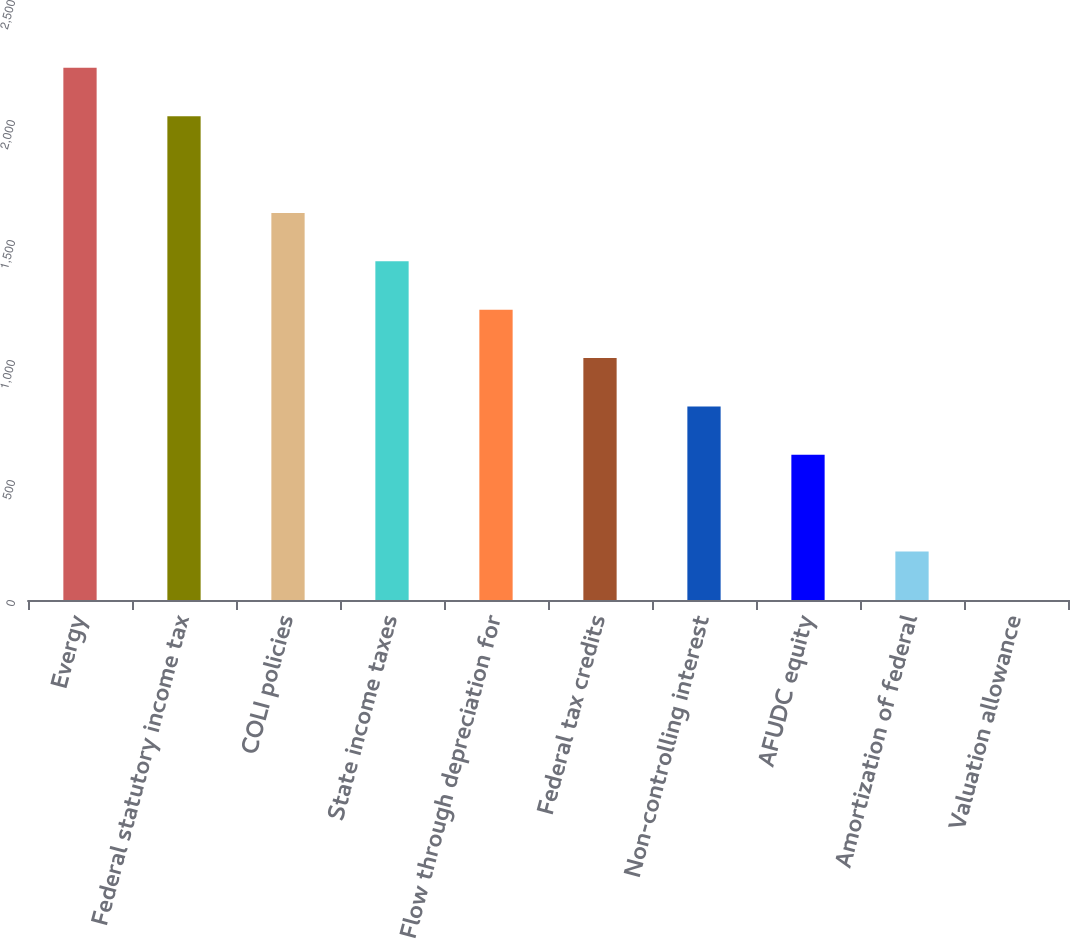<chart> <loc_0><loc_0><loc_500><loc_500><bar_chart><fcel>Evergy<fcel>Federal statutory income tax<fcel>COLI policies<fcel>State income taxes<fcel>Flow through depreciation for<fcel>Federal tax credits<fcel>Non-controlling interest<fcel>AFUDC equity<fcel>Amortization of federal<fcel>Valuation allowance<nl><fcel>2217.56<fcel>2016<fcel>1612.88<fcel>1411.32<fcel>1209.76<fcel>1008.2<fcel>806.64<fcel>605.08<fcel>201.96<fcel>0.4<nl></chart> 